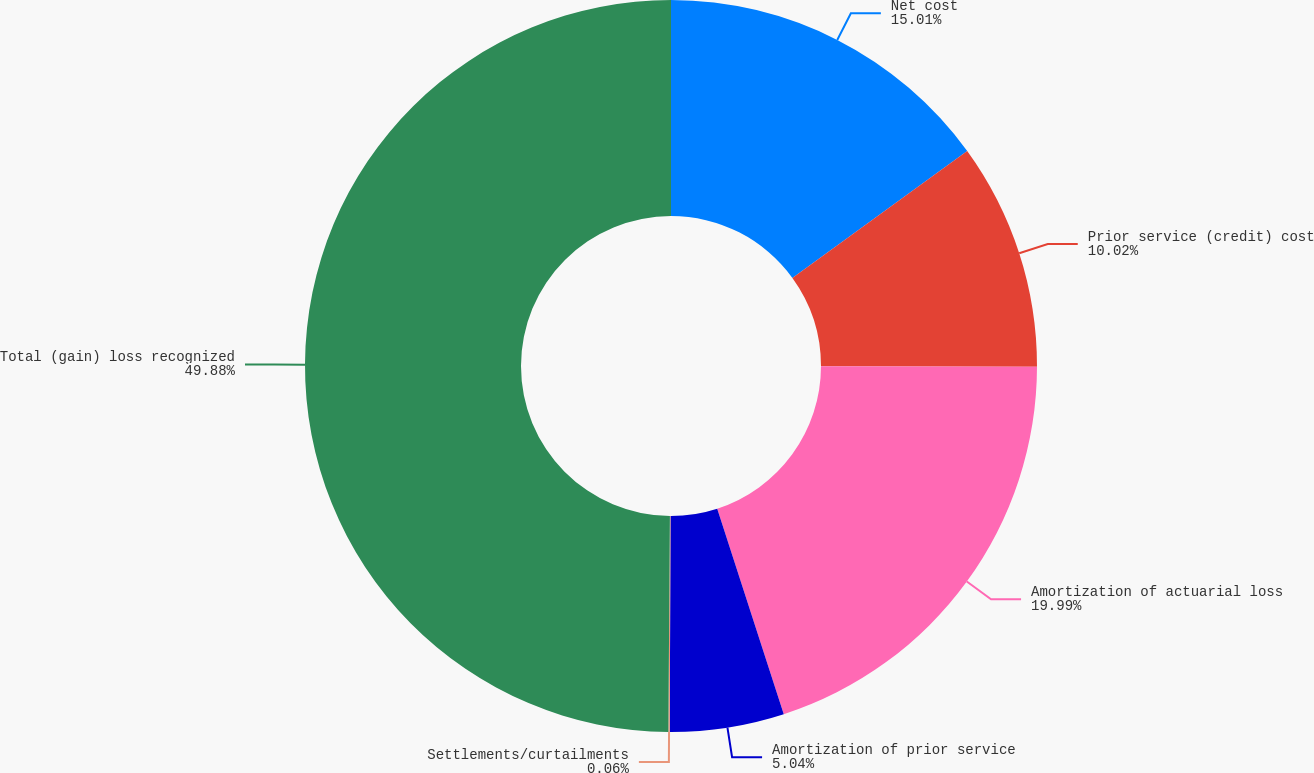<chart> <loc_0><loc_0><loc_500><loc_500><pie_chart><fcel>Net cost<fcel>Prior service (credit) cost<fcel>Amortization of actuarial loss<fcel>Amortization of prior service<fcel>Settlements/curtailments<fcel>Total (gain) loss recognized<nl><fcel>15.01%<fcel>10.02%<fcel>19.99%<fcel>5.04%<fcel>0.06%<fcel>49.89%<nl></chart> 